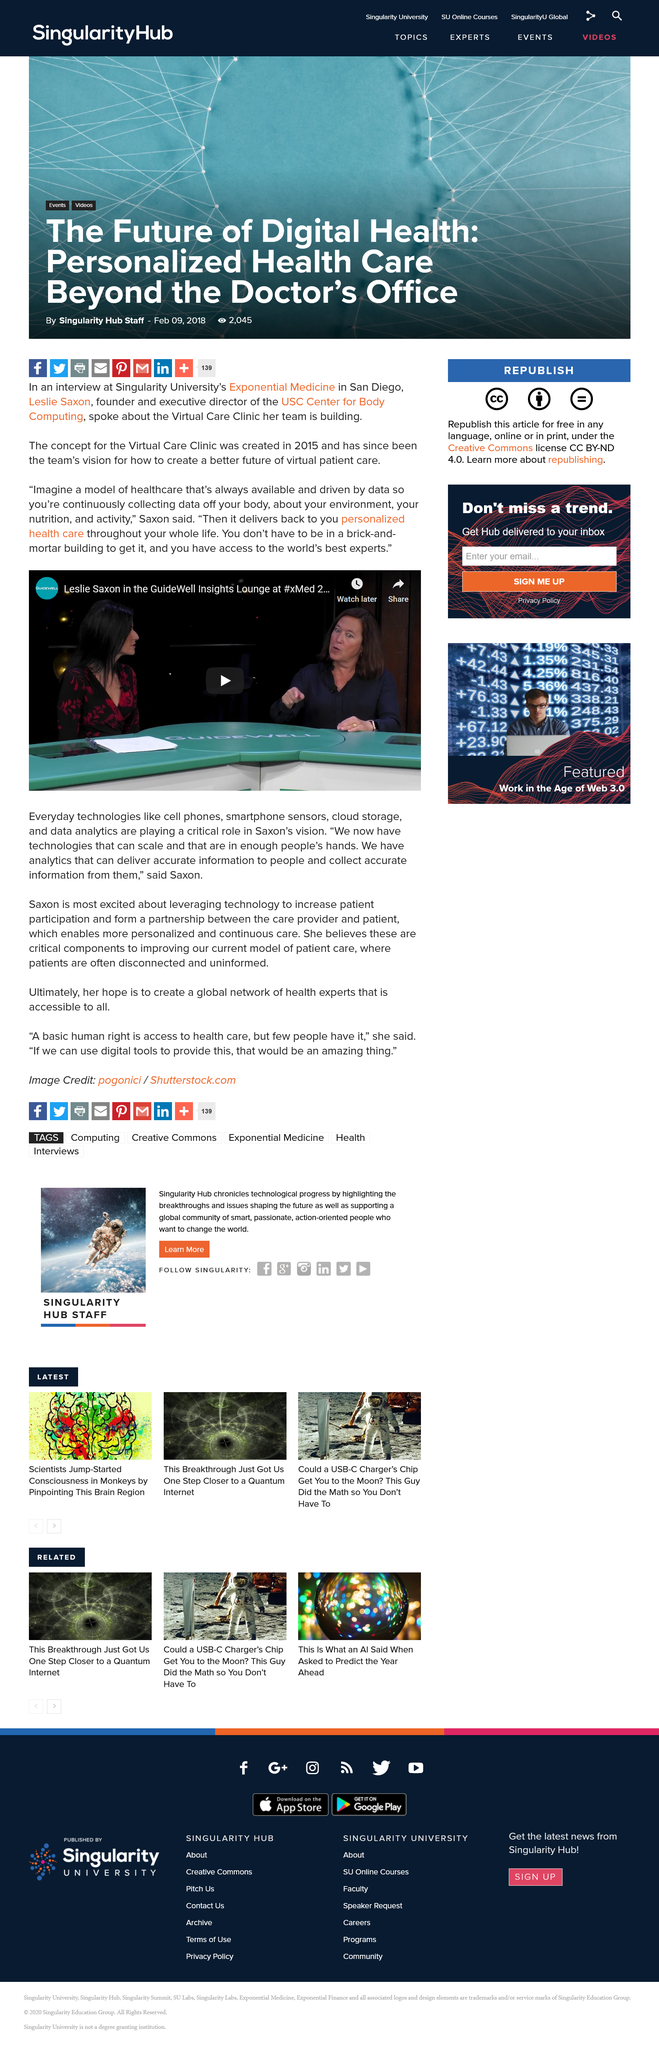Outline some significant characteristics in this image. Saxon's given name is Leslie. The concept for Virtual Care Clinic was created in the year 2015. The healthcare model not only continuously collects data from your body and environment, but it also delivers nutrition and activity recommendations to help you maintain a healthy lifestyle. 